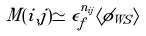Convert formula to latex. <formula><loc_0><loc_0><loc_500><loc_500>M ( i , j ) \simeq \epsilon _ { f } ^ { n _ { i j } } \langle \phi _ { W S } \rangle</formula> 